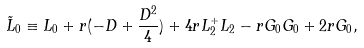<formula> <loc_0><loc_0><loc_500><loc_500>\tilde { L } _ { 0 } \equiv L _ { 0 } + r ( - D + \frac { D ^ { 2 } } { 4 } ) + 4 r L ^ { + } _ { 2 } L _ { 2 } - r G _ { 0 } G _ { 0 } + 2 r G _ { 0 } ,</formula> 